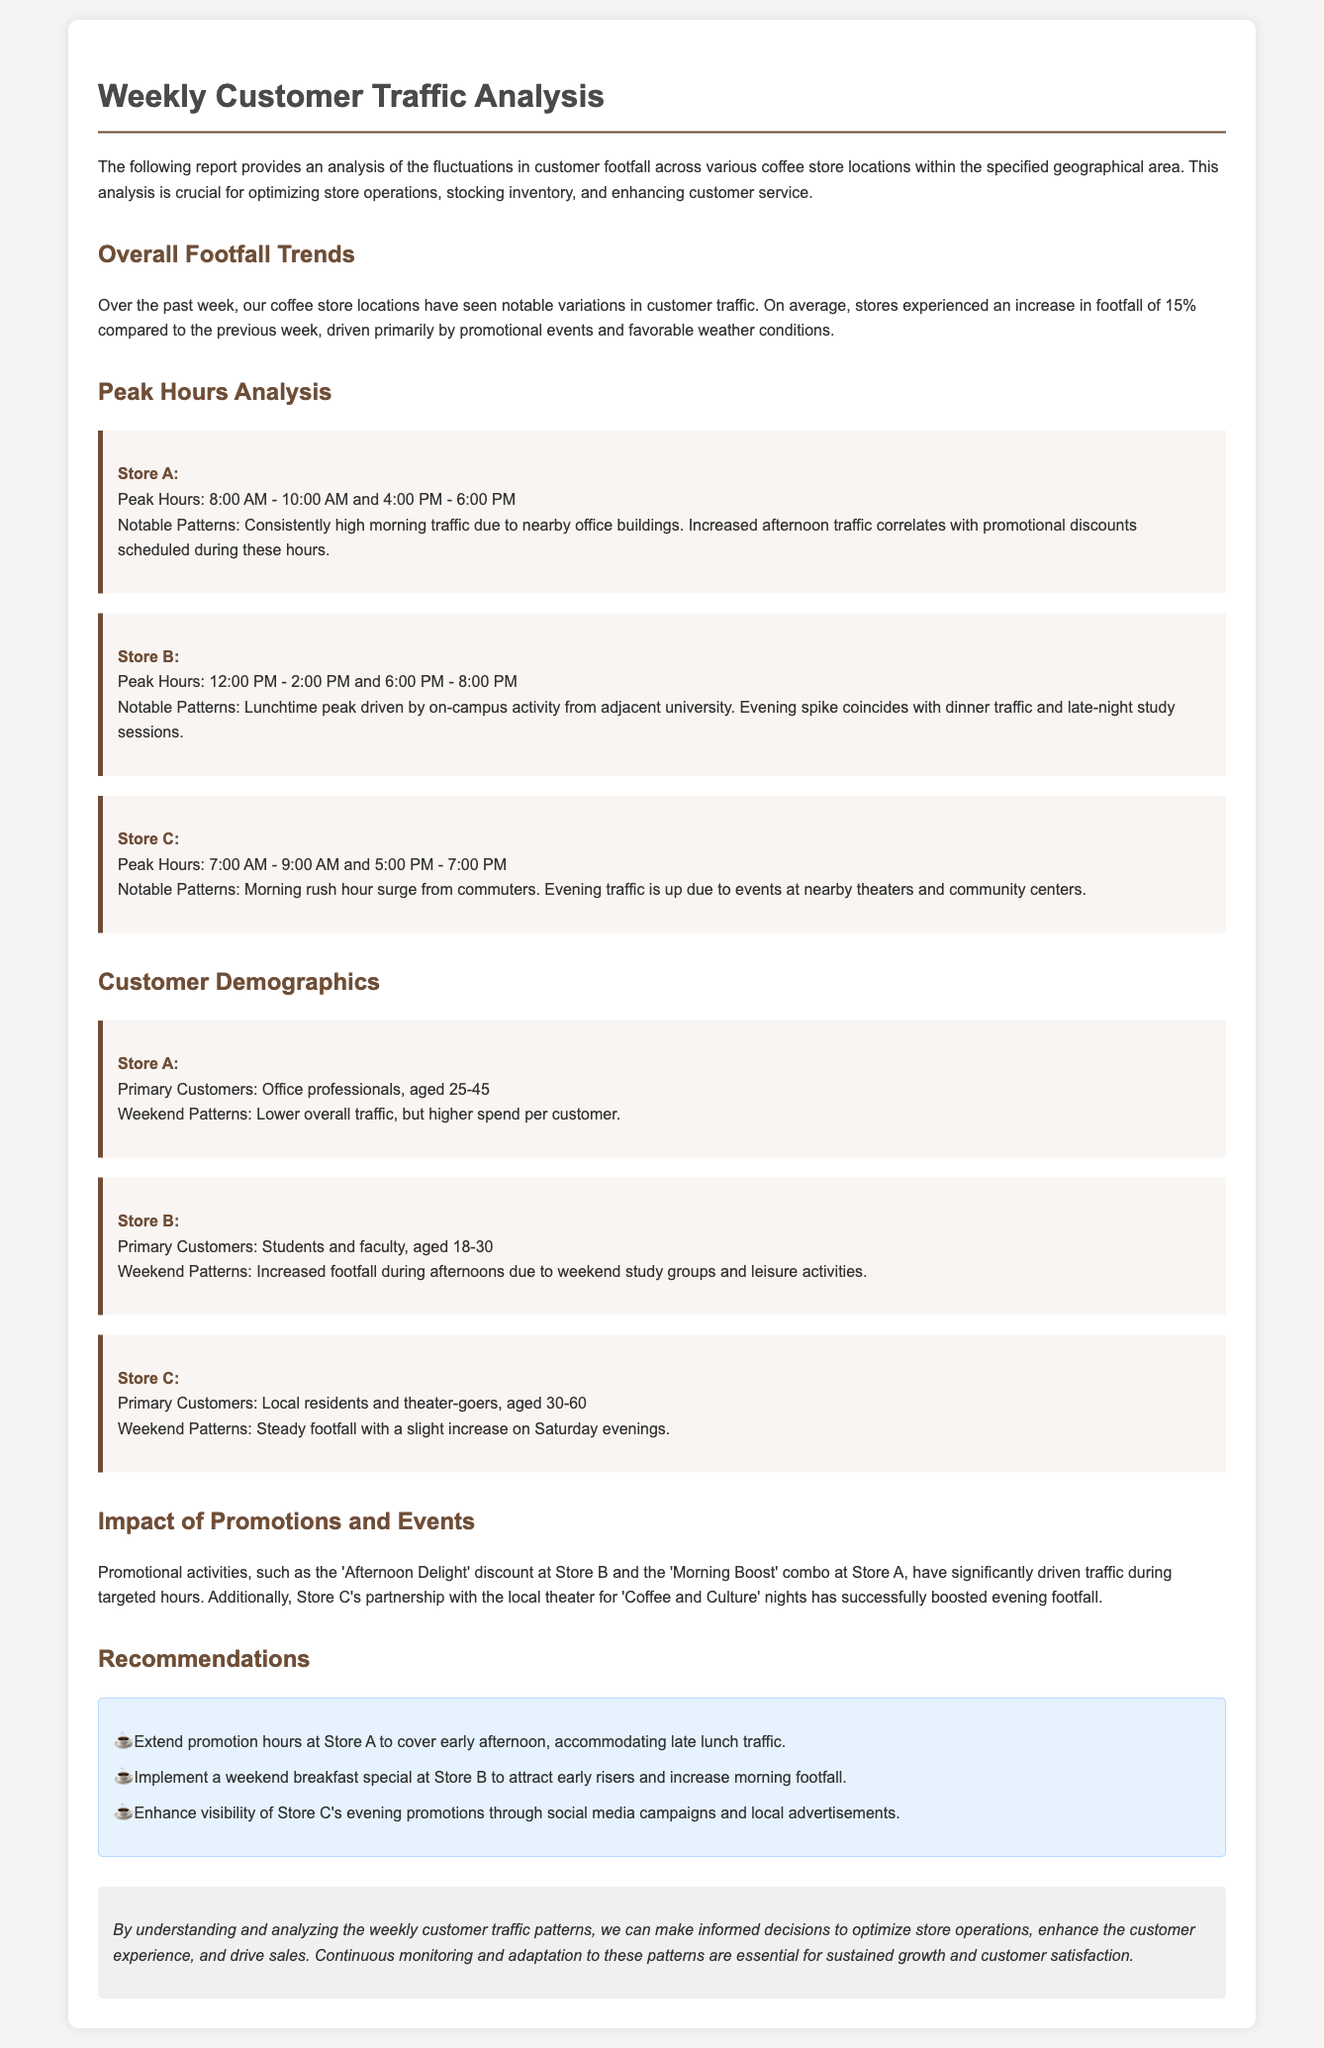What is the overall increase in footfall compared to the previous week? The document states that there was an increase in footfall of 15% compared to the previous week.
Answer: 15% What are the peak hours for Store B? The document lists the peak hours for Store B as 12:00 PM - 2:00 PM and 6:00 PM - 8:00 PM.
Answer: 12:00 PM - 2:00 PM and 6:00 PM - 8:00 PM Who are the primary customers of Store C? The document specifies that the primary customers of Store C are local residents and theater-goers, aged 30-60.
Answer: Local residents and theater-goers, aged 30-60 What promotional activity is driving traffic at Store A? The report mentions the 'Morning Boost' combo at Store A is driving traffic during specific hours.
Answer: Morning Boost What is a recommended action for Store B? The document recommends implementing a weekend breakfast special at Store B.
Answer: Implement a weekend breakfast special What notable pattern is observed for Store A's afternoon traffic? The document states that increased afternoon traffic at Store A correlates with promotional discounts scheduled during these hours.
Answer: Promotional discounts During which hours does Store C experience higher traffic due to nearby events? The report indicates that evening traffic at Store C is up due to events at nearby theaters and community centers, specifically from 5:00 PM - 7:00 PM.
Answer: 5:00 PM - 7:00 PM What is the impact of promotional activities on customer traffic? The document discusses that promotional activities significantly drive traffic during targeted hours, impacting customer flow positively.
Answer: Drive traffic What is the purpose of this weekly customer traffic analysis? The document states that the analysis is crucial for optimizing store operations, stocking inventory, and enhancing customer service.
Answer: Optimize store operations 